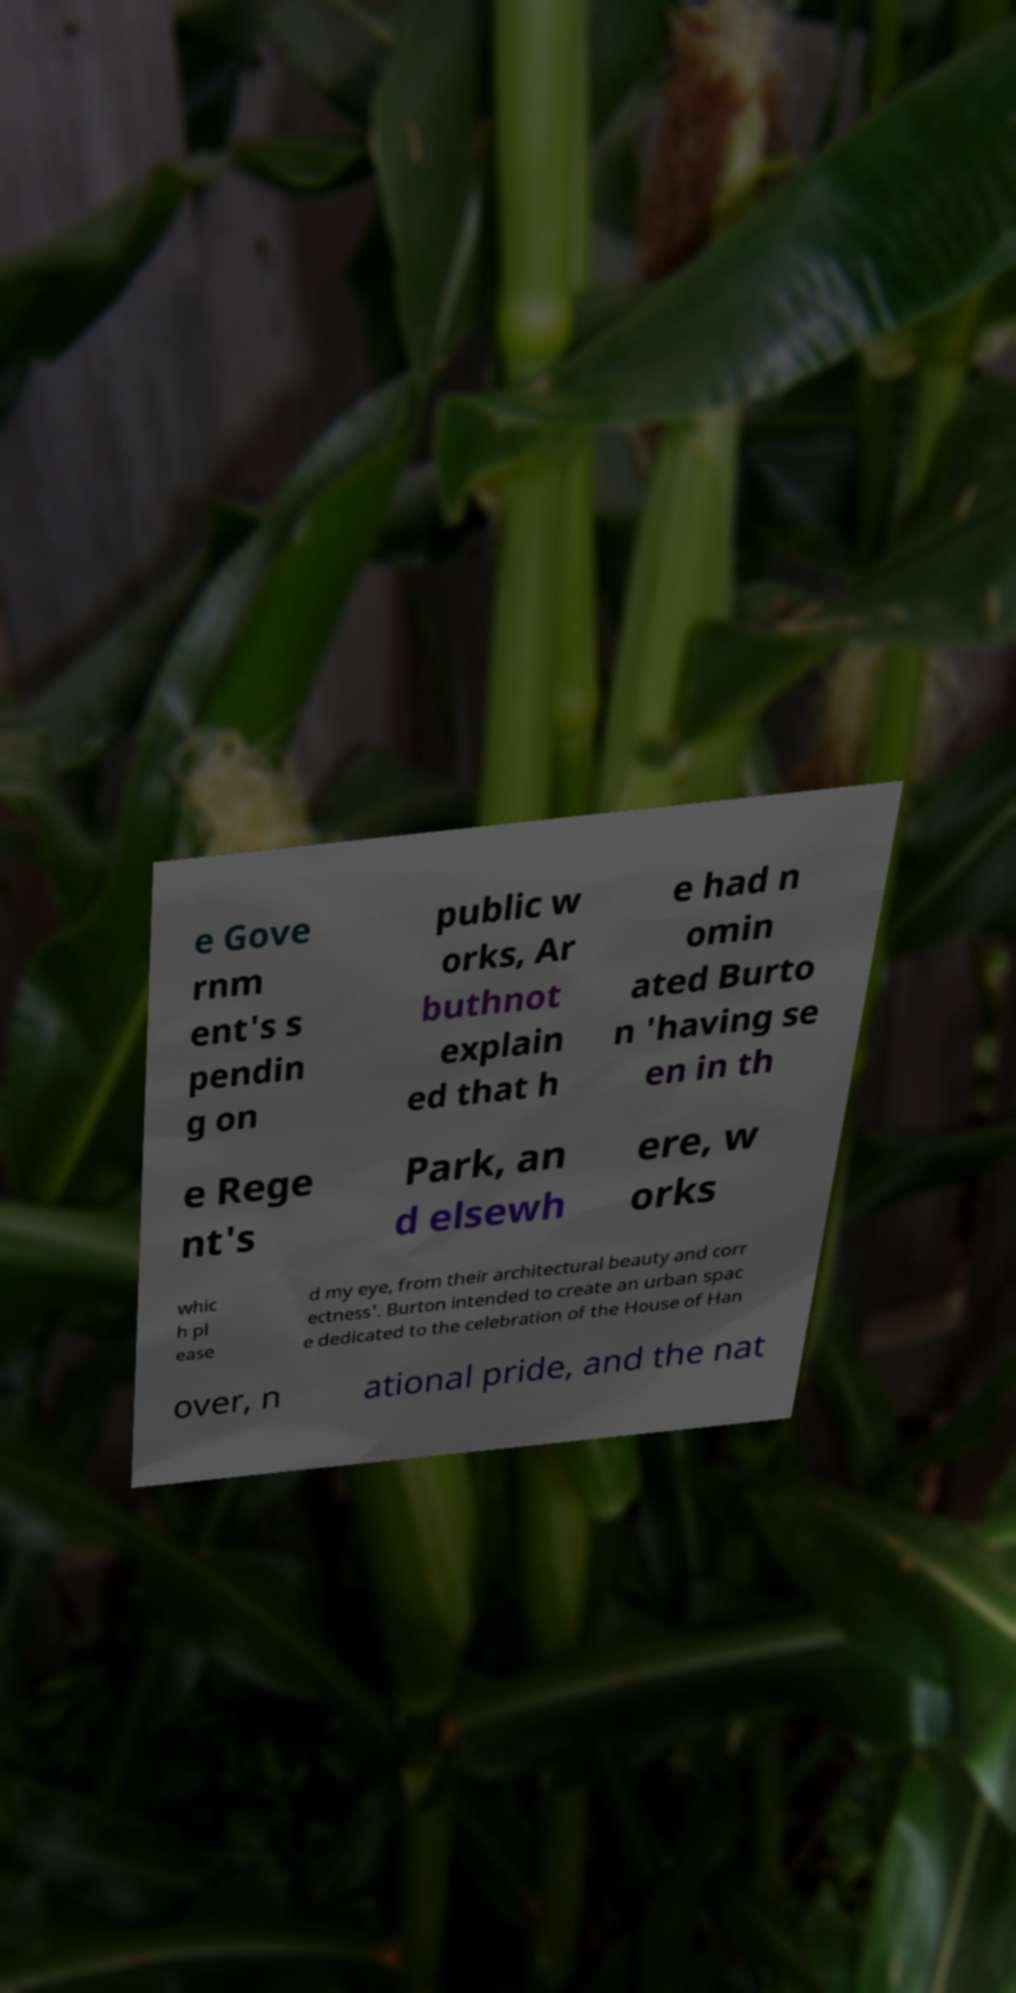Can you accurately transcribe the text from the provided image for me? e Gove rnm ent's s pendin g on public w orks, Ar buthnot explain ed that h e had n omin ated Burto n 'having se en in th e Rege nt's Park, an d elsewh ere, w orks whic h pl ease d my eye, from their architectural beauty and corr ectness'. Burton intended to create an urban spac e dedicated to the celebration of the House of Han over, n ational pride, and the nat 